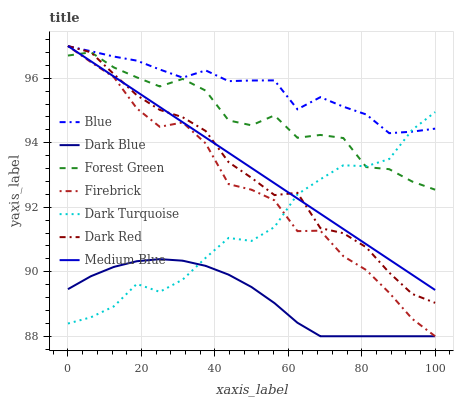Does Dark Blue have the minimum area under the curve?
Answer yes or no. Yes. Does Blue have the maximum area under the curve?
Answer yes or no. Yes. Does Dark Red have the minimum area under the curve?
Answer yes or no. No. Does Dark Red have the maximum area under the curve?
Answer yes or no. No. Is Medium Blue the smoothest?
Answer yes or no. Yes. Is Forest Green the roughest?
Answer yes or no. Yes. Is Dark Red the smoothest?
Answer yes or no. No. Is Dark Red the roughest?
Answer yes or no. No. Does Dark Red have the lowest value?
Answer yes or no. No. Does Medium Blue have the highest value?
Answer yes or no. Yes. Does Dark Blue have the highest value?
Answer yes or no. No. Is Dark Blue less than Dark Red?
Answer yes or no. Yes. Is Dark Red greater than Dark Blue?
Answer yes or no. Yes. Does Forest Green intersect Firebrick?
Answer yes or no. Yes. Is Forest Green less than Firebrick?
Answer yes or no. No. Is Forest Green greater than Firebrick?
Answer yes or no. No. Does Dark Blue intersect Dark Red?
Answer yes or no. No. 